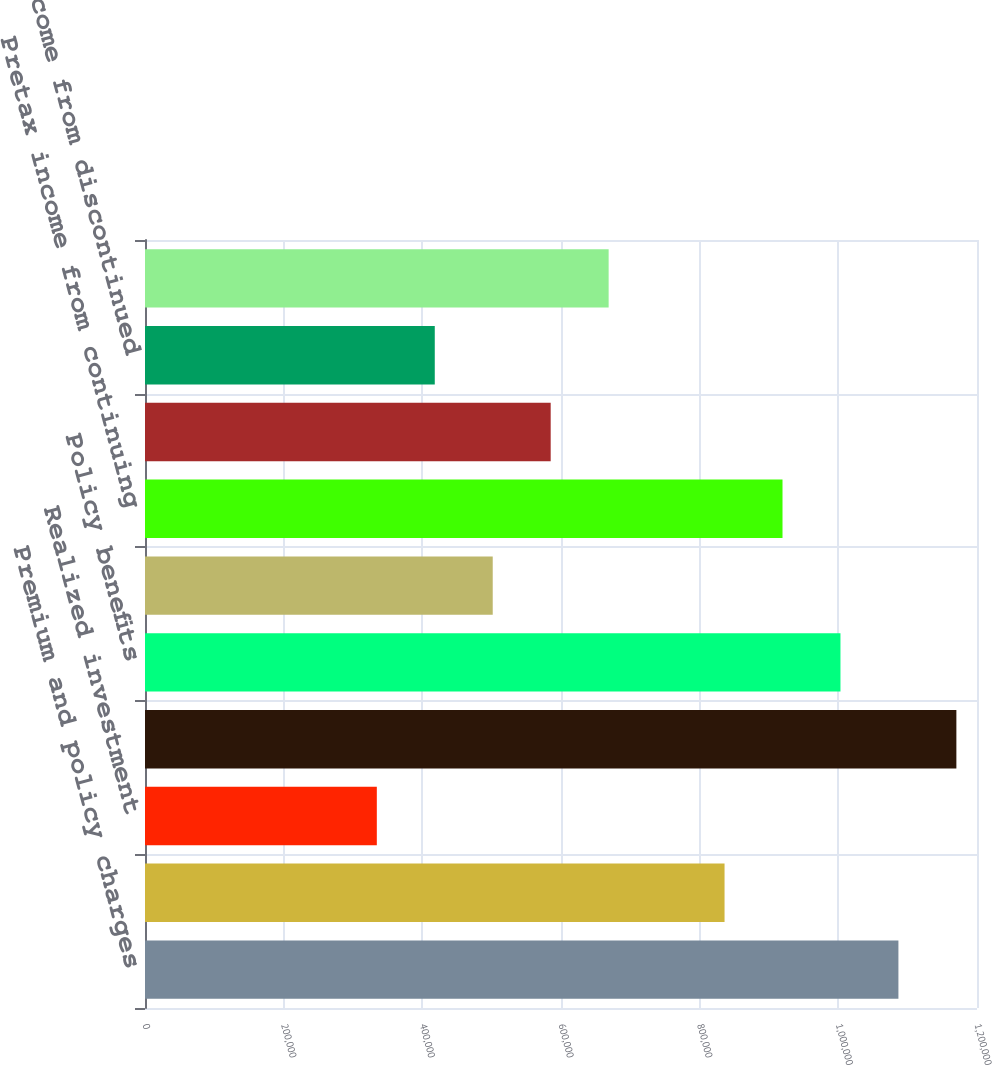<chart> <loc_0><loc_0><loc_500><loc_500><bar_chart><fcel>Premium and policy charges<fcel>Net investment income<fcel>Realized investment<fcel>Total revenues<fcel>Policy benefits<fcel>Amortization of acquisition<fcel>Pretax income from continuing<fcel>Income from continuing<fcel>Income from discontinued<fcel>Net income<nl><fcel>1.08666e+06<fcel>835895<fcel>334358<fcel>1.17025e+06<fcel>1.00307e+06<fcel>501537<fcel>919484<fcel>585127<fcel>417948<fcel>668716<nl></chart> 